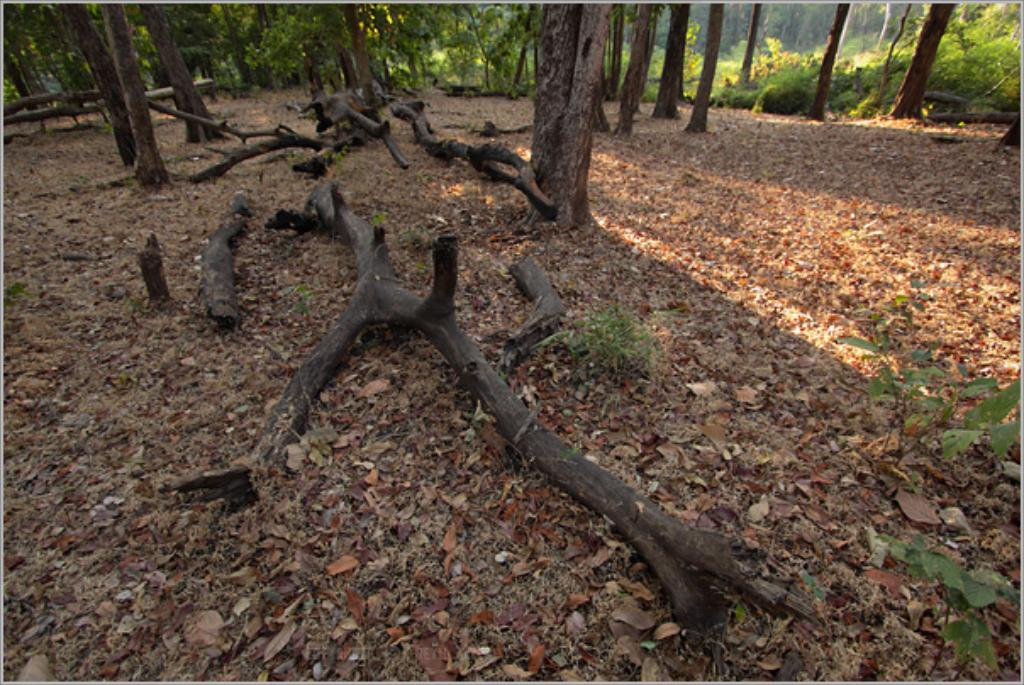What is on the ground in the image? There are dried leaves and branches on the ground. What can be seen in the background of the image? There are plants and multiple trees in the background. What type of discussion is taking place between the fowl in the image? There are no fowl present in the image, so there is no discussion taking place. What color is the gold in the image? There is no gold present in the image. 